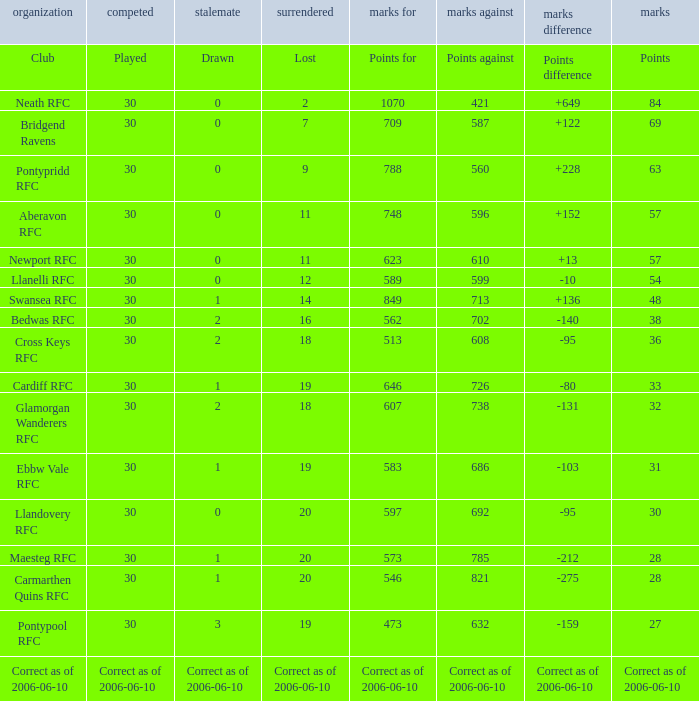What is Drawn, when Played is "Correct as of 2006-06-10"? Correct as of 2006-06-10. 